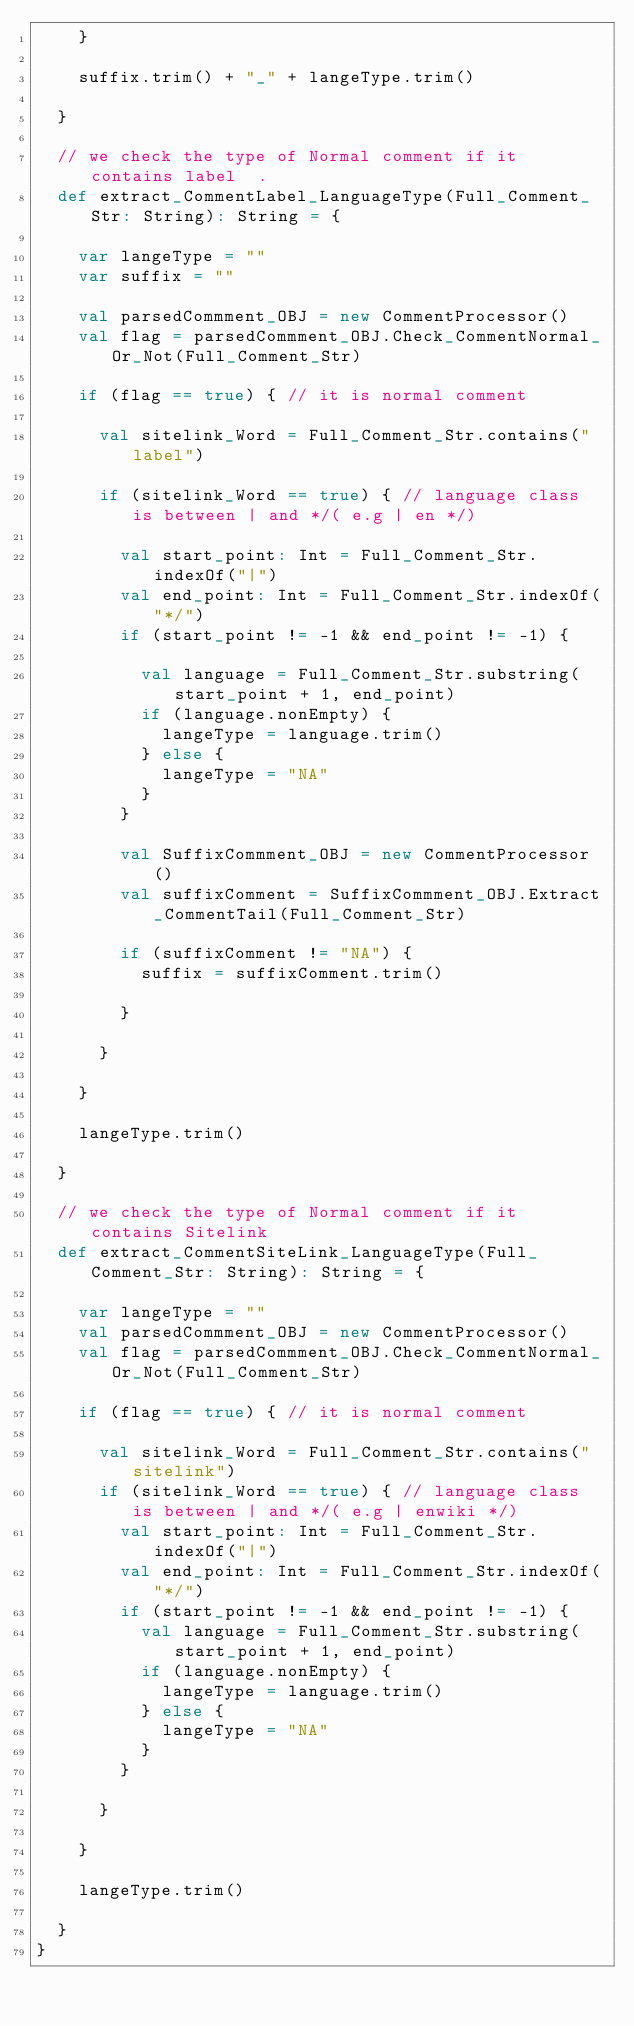Convert code to text. <code><loc_0><loc_0><loc_500><loc_500><_Scala_>    }

    suffix.trim() + "_" + langeType.trim()

  }

  // we check the type of Normal comment if it contains label  .
  def extract_CommentLabel_LanguageType(Full_Comment_Str: String): String = {

    var langeType = ""
    var suffix = ""

    val parsedCommment_OBJ = new CommentProcessor()
    val flag = parsedCommment_OBJ.Check_CommentNormal_Or_Not(Full_Comment_Str)

    if (flag == true) { // it is normal comment

      val sitelink_Word = Full_Comment_Str.contains("label")

      if (sitelink_Word == true) { // language class is between | and */( e.g | en */)

        val start_point: Int = Full_Comment_Str.indexOf("|")
        val end_point: Int = Full_Comment_Str.indexOf("*/")
        if (start_point != -1 && end_point != -1) {

          val language = Full_Comment_Str.substring(start_point + 1, end_point)
          if (language.nonEmpty) {
            langeType = language.trim()
          } else {
            langeType = "NA"
          }
        }

        val SuffixCommment_OBJ = new CommentProcessor()
        val suffixComment = SuffixCommment_OBJ.Extract_CommentTail(Full_Comment_Str)

        if (suffixComment != "NA") {
          suffix = suffixComment.trim()

        }

      }

    }

    langeType.trim()

  }

  // we check the type of Normal comment if it contains Sitelink
  def extract_CommentSiteLink_LanguageType(Full_Comment_Str: String): String = {

    var langeType = ""
    val parsedCommment_OBJ = new CommentProcessor()
    val flag = parsedCommment_OBJ.Check_CommentNormal_Or_Not(Full_Comment_Str)

    if (flag == true) { // it is normal comment

      val sitelink_Word = Full_Comment_Str.contains("sitelink")
      if (sitelink_Word == true) { // language class is between | and */( e.g | enwiki */)
        val start_point: Int = Full_Comment_Str.indexOf("|")
        val end_point: Int = Full_Comment_Str.indexOf("*/")
        if (start_point != -1 && end_point != -1) {
          val language = Full_Comment_Str.substring(start_point + 1, end_point)
          if (language.nonEmpty) {
            langeType = language.trim()
          } else {
            langeType = "NA"
          }
        }

      }

    }

    langeType.trim()

  }
}
</code> 